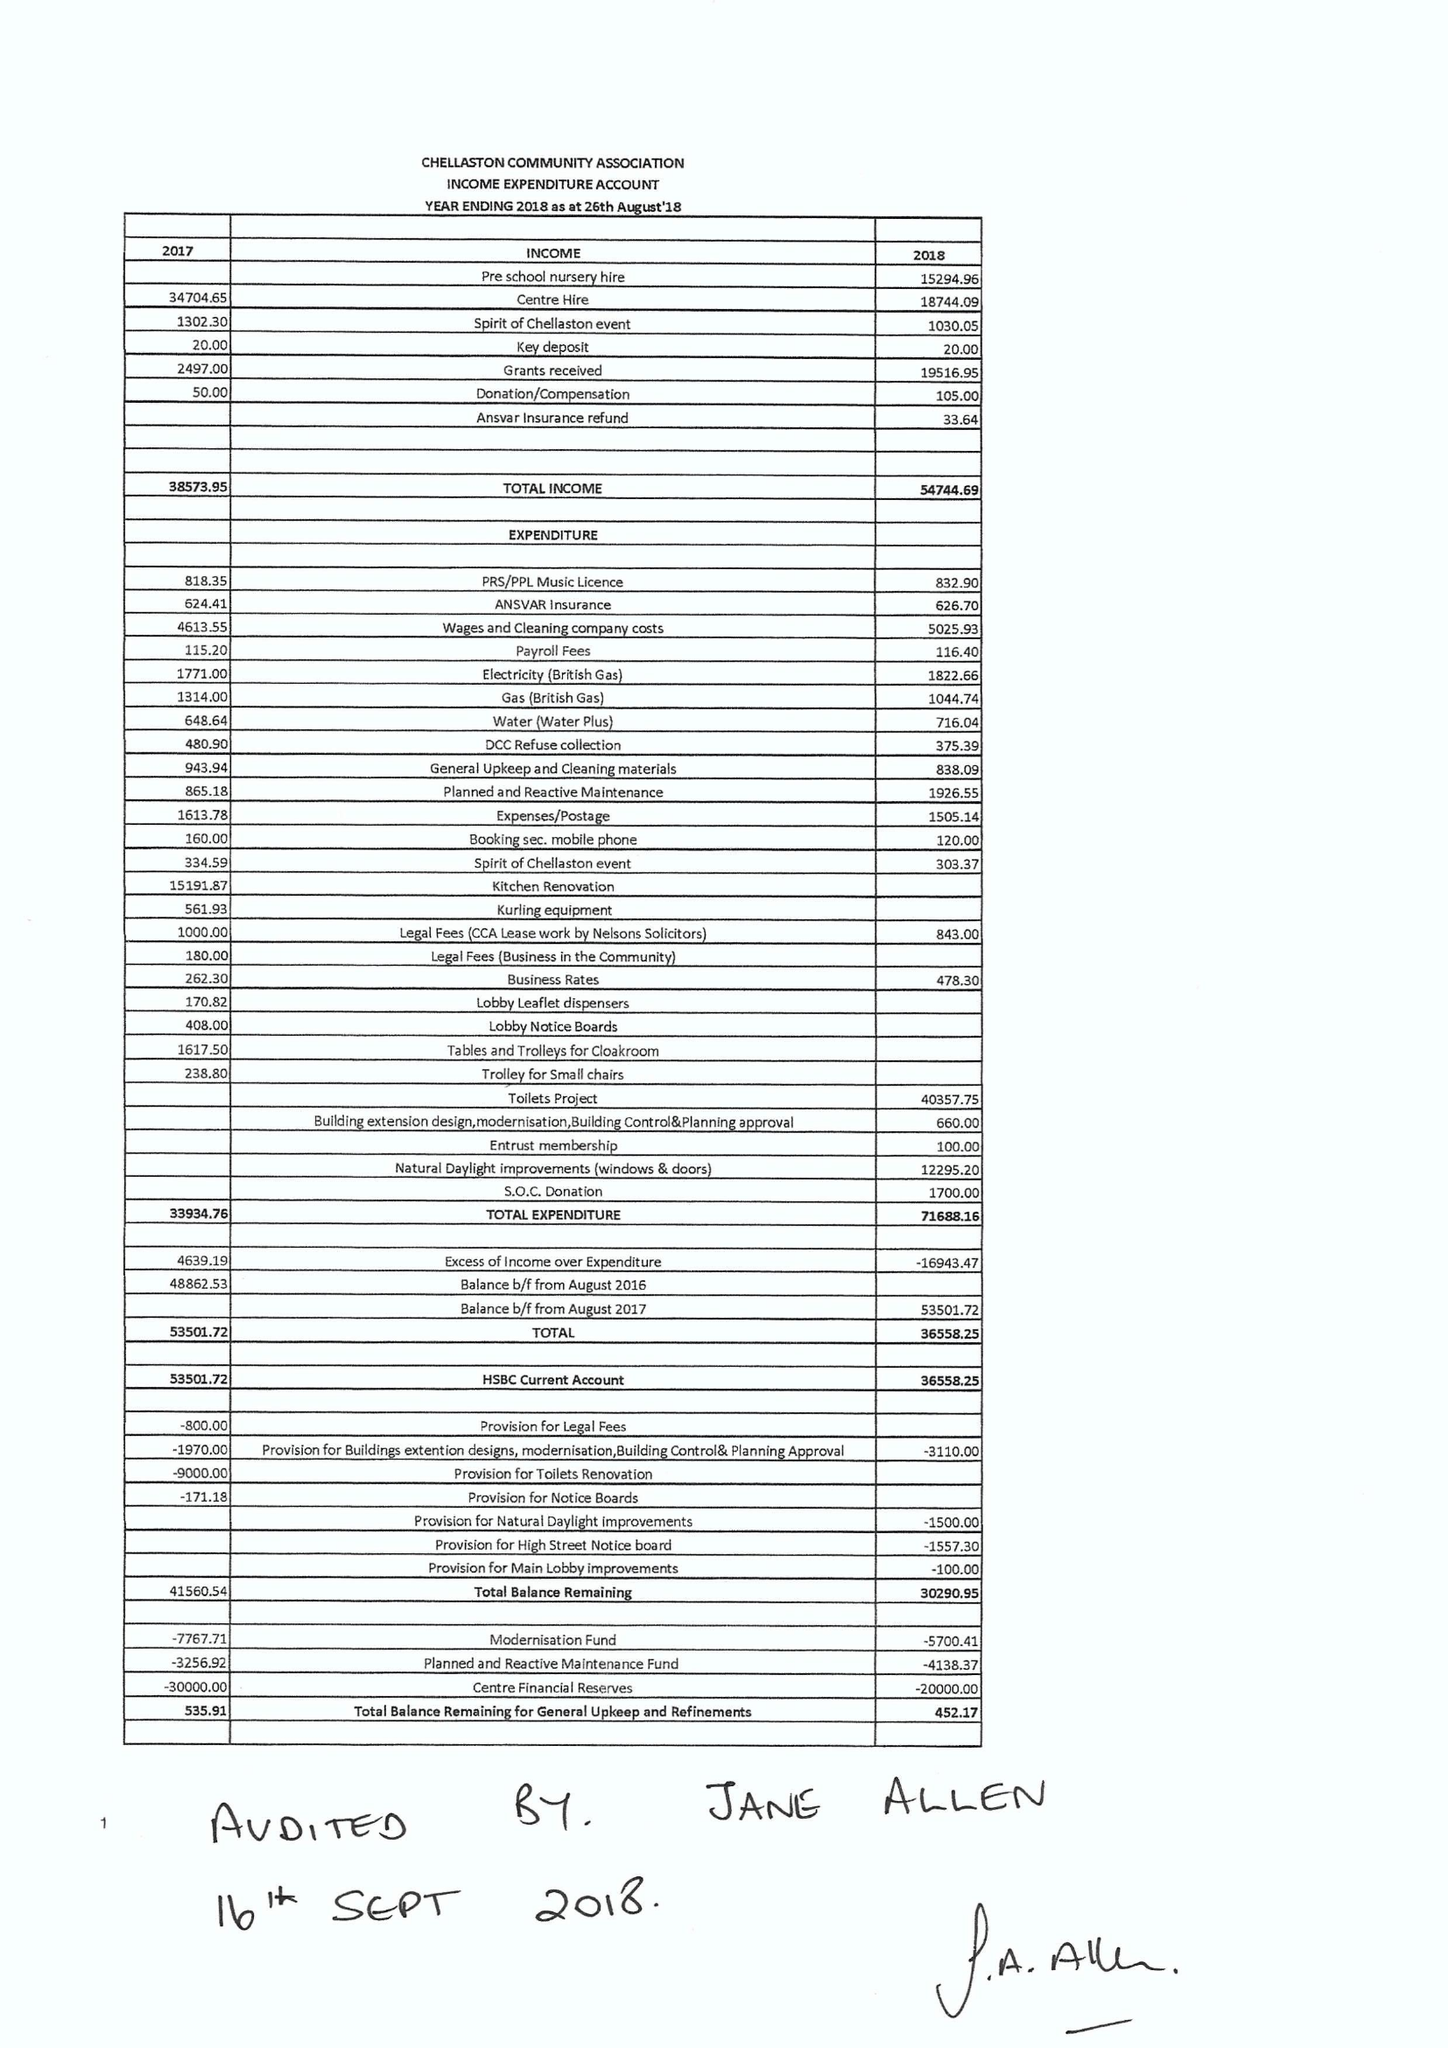What is the value for the charity_name?
Answer the question using a single word or phrase. The Chellaston Community Association 